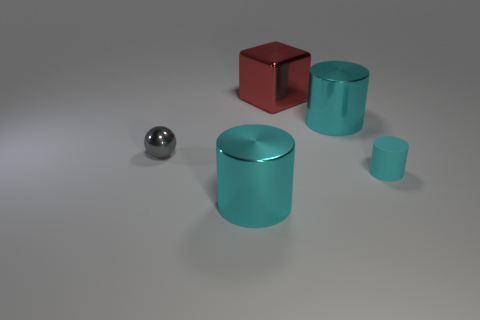There is a cylinder that is left of the big cyan metallic cylinder that is to the right of the red shiny block; how many small cylinders are in front of it?
Make the answer very short. 0. There is a small matte object; is its color the same as the shiny cylinder behind the gray object?
Provide a succinct answer. Yes. Is the number of cyan metallic objects behind the tiny cyan object greater than the number of red cylinders?
Your answer should be very brief. Yes. What number of things are either large red things behind the tiny rubber cylinder or large cyan cylinders that are on the right side of the large red thing?
Your answer should be very brief. 2. The red cube that is the same material as the small gray object is what size?
Ensure brevity in your answer.  Large. Do the cyan metal object that is behind the small gray metallic object and the rubber thing have the same shape?
Give a very brief answer. Yes. What number of gray objects are tiny metallic balls or small cylinders?
Keep it short and to the point. 1. What number of other objects are there of the same shape as the gray shiny object?
Your response must be concise. 0. There is a cyan thing that is in front of the sphere and on the right side of the red metal thing; what is its shape?
Provide a short and direct response. Cylinder. There is a gray shiny thing; are there any big red things in front of it?
Give a very brief answer. No. 